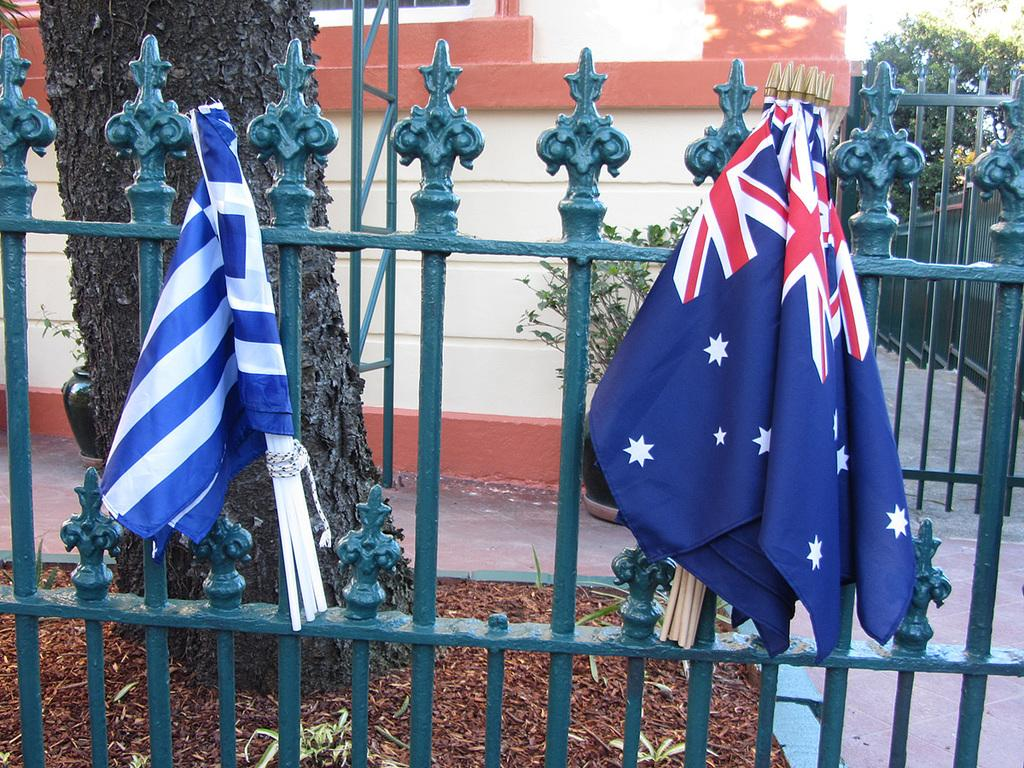How many flags are visible in the image? There are two flags in the image. What are the flags attached to? The flags are tied to an iron fence. What is the color of the iron fence? The iron fence is green in color. What can be seen in the background of the image? There is a tree trunk and a building in the background of the image. What type of marble is used to decorate the string in the image? There is no marble or string present in the image. 